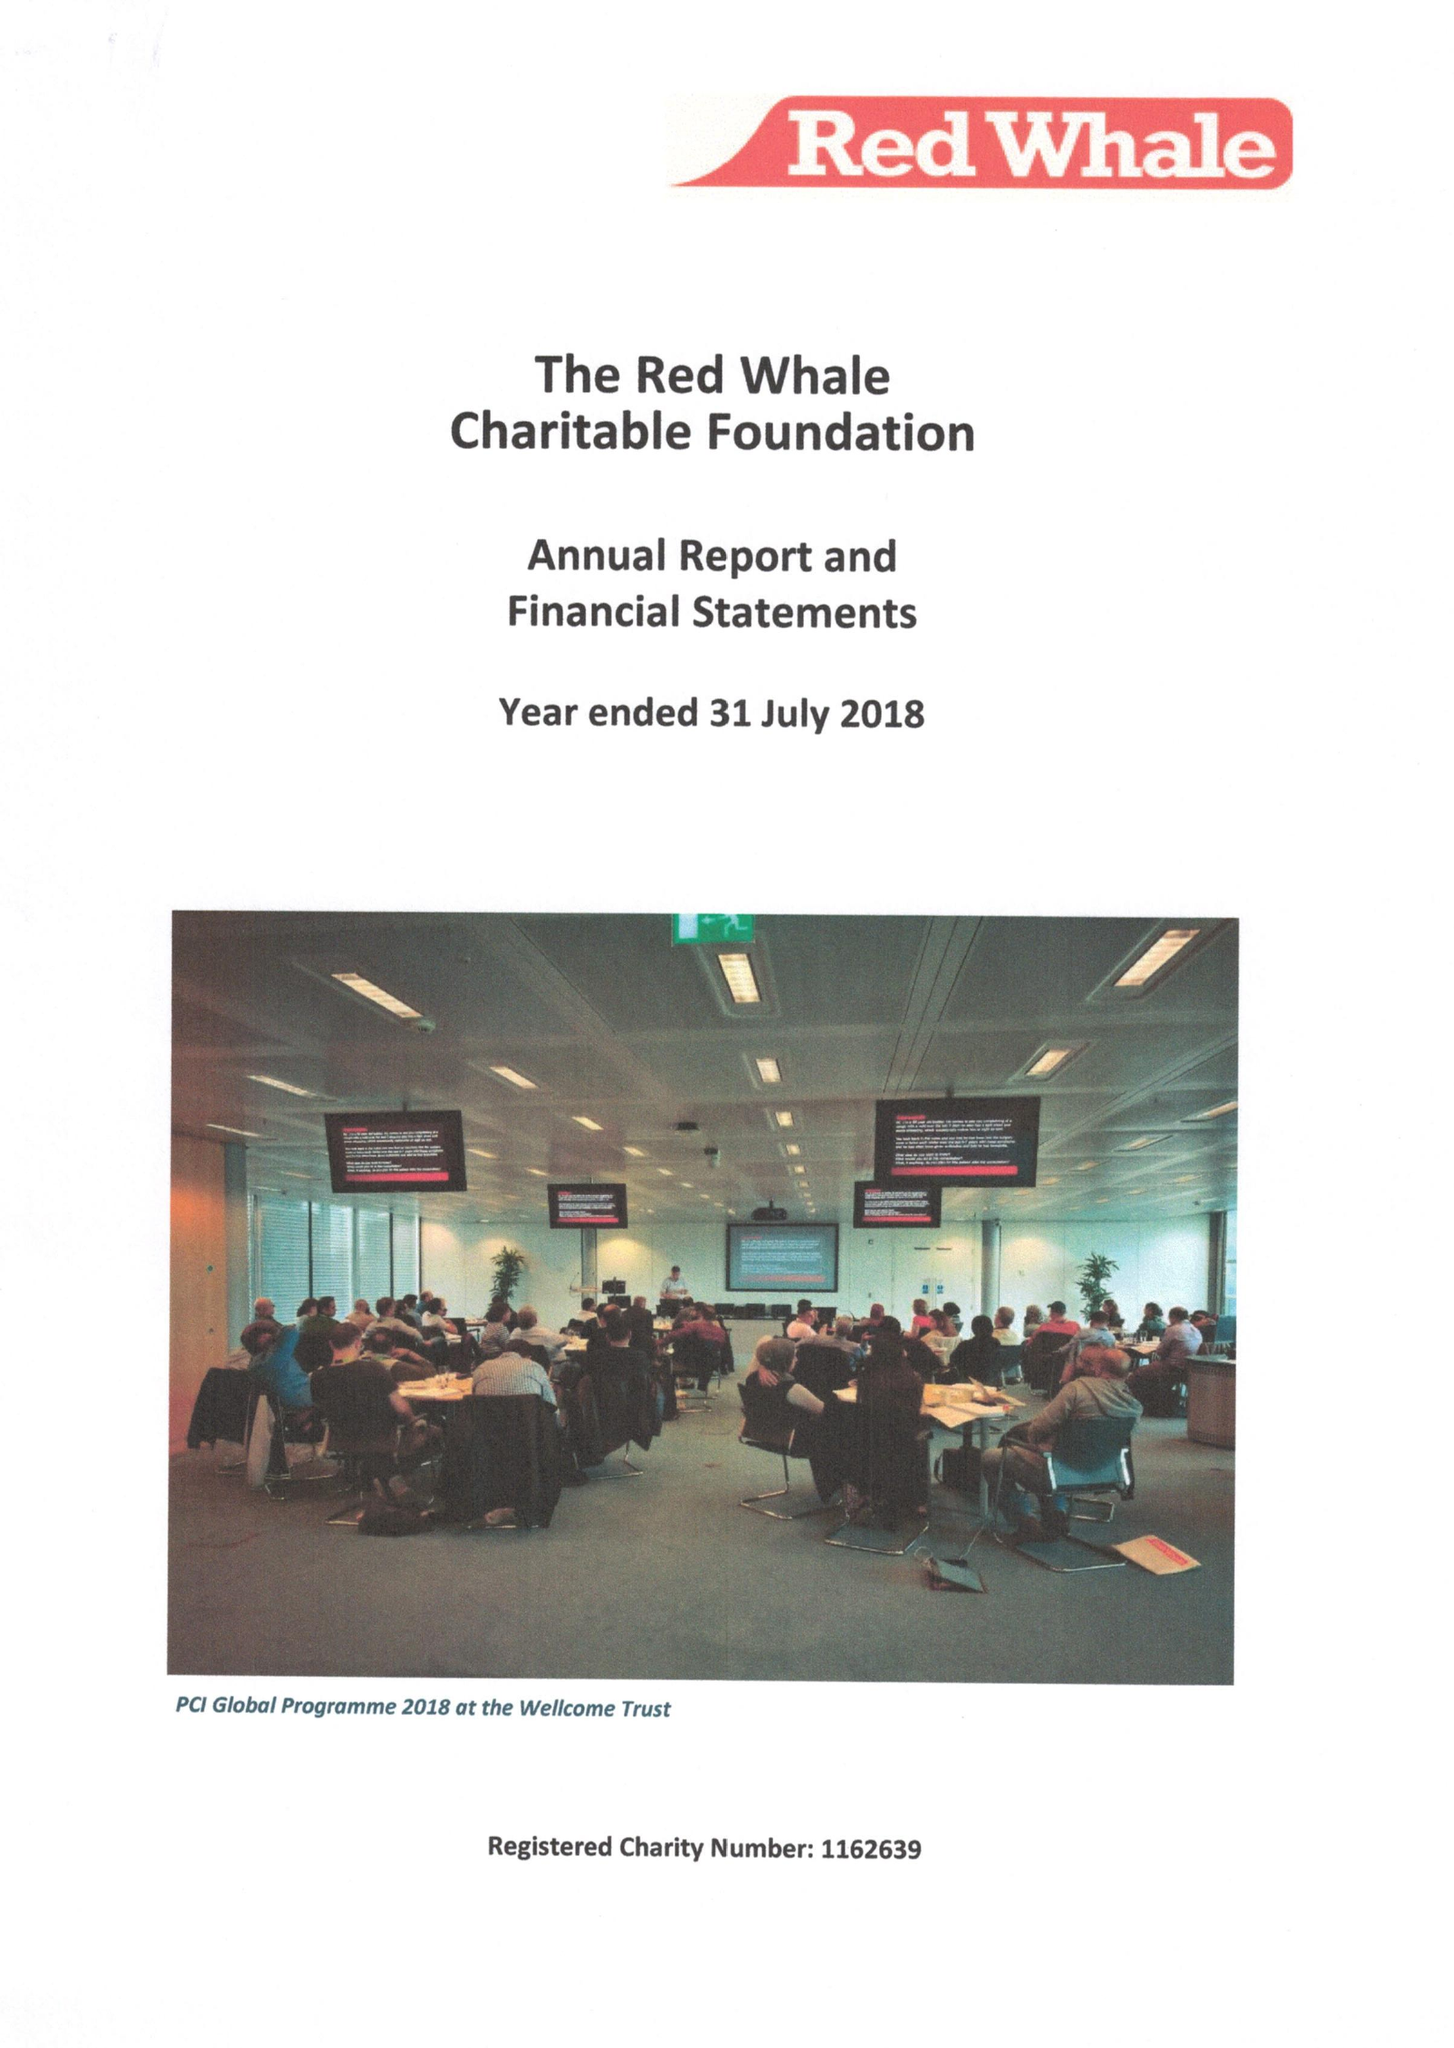What is the value for the address__post_town?
Answer the question using a single word or phrase. READING 